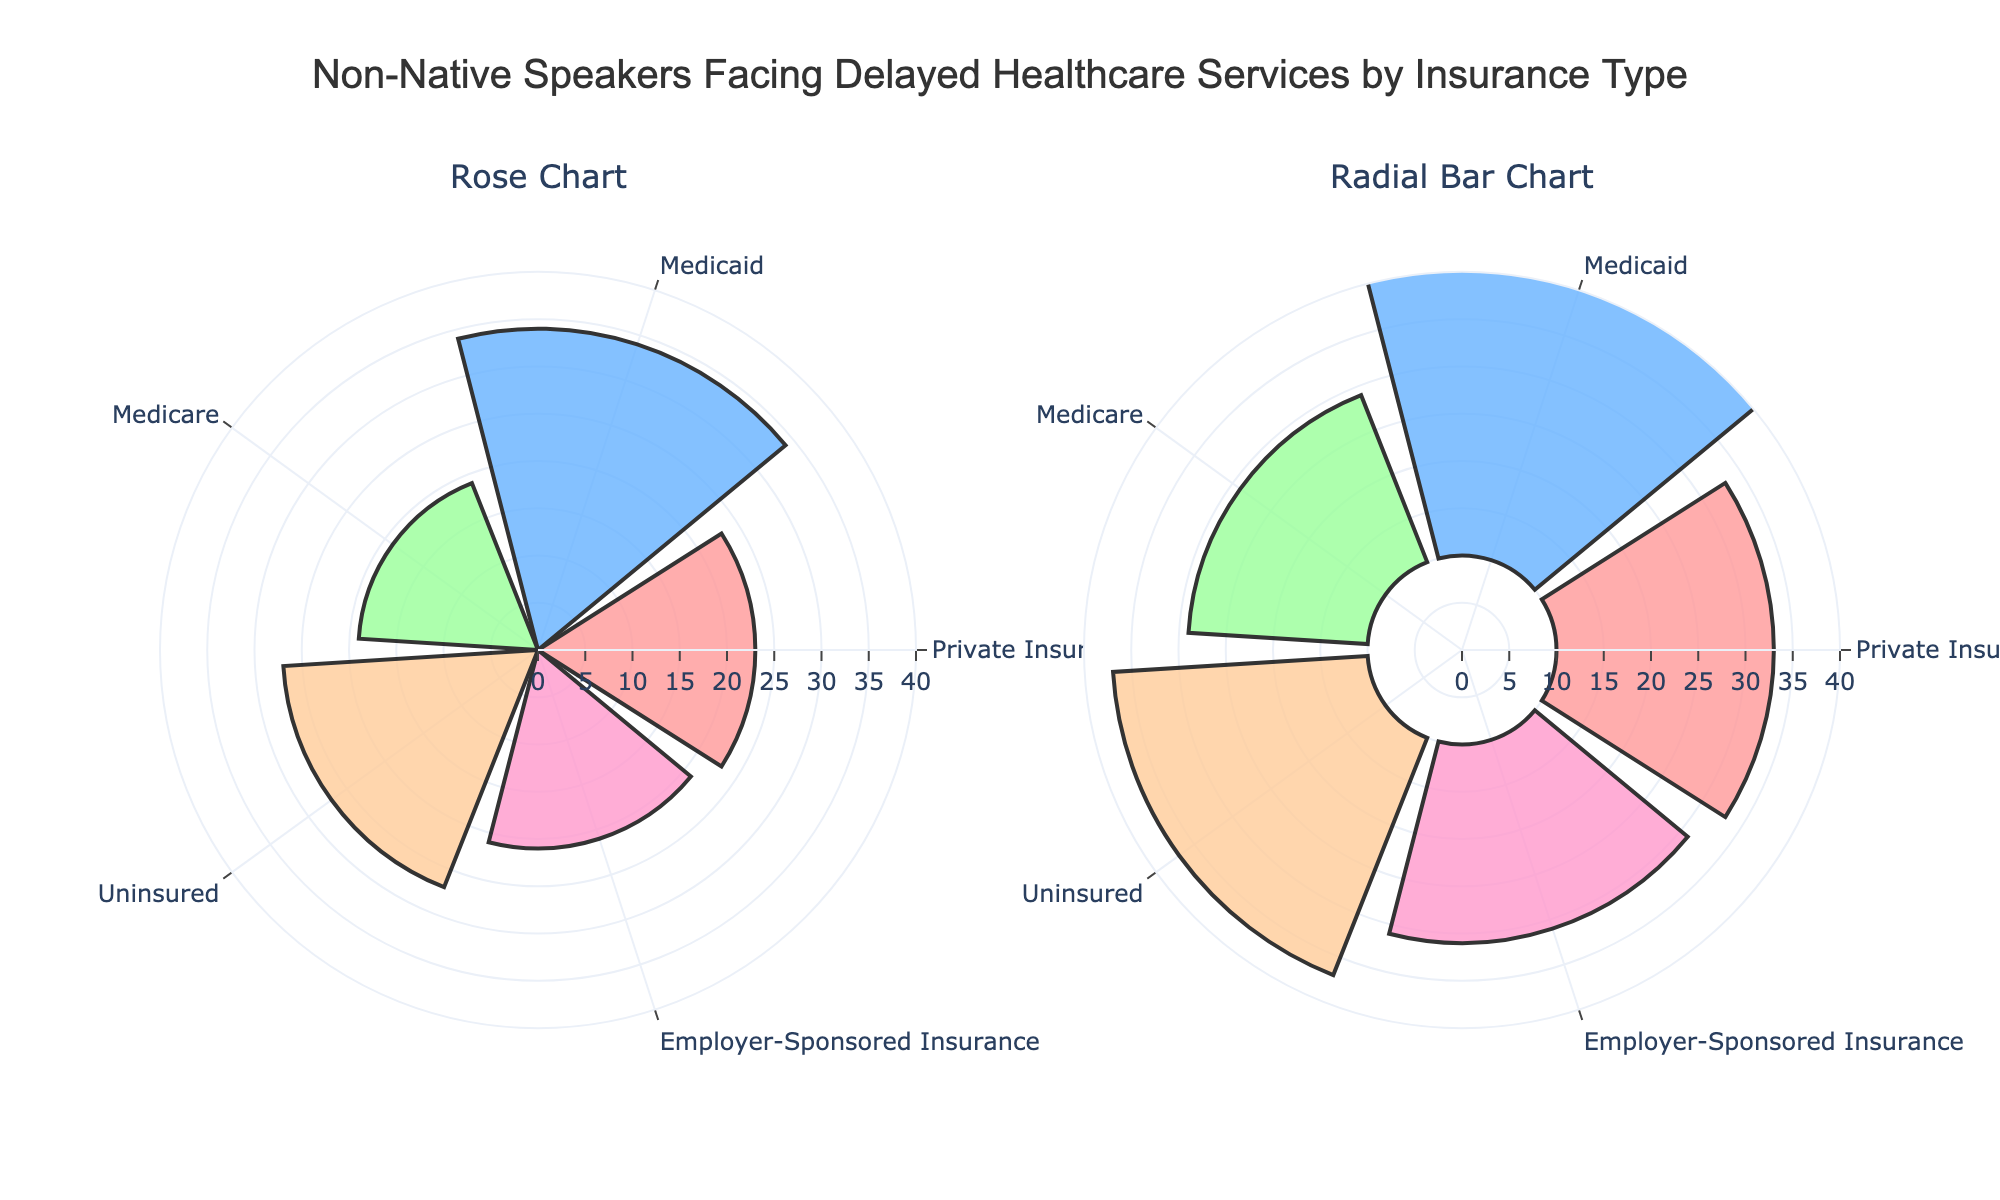What's the title of the figure? The title is usually at the top of the plot. In this case, it’s written clearly in a prominent position.
Answer: Non-Native Speakers Facing Delayed Healthcare Services by Insurance Type What are the insurance types shown in the figure? The insurance types are listed in the angular axis of the polar plots. Each bar in both charts corresponds to a different insurance type.
Answer: Private Insurance, Medicaid, Medicare, Uninsured, Employer-Sponsored Insurance How many non-native speakers face delays with Medicaid? Check the bar height corresponding to Medicaid. In both charts, the bar representing Medicaid shows the number of non-native speakers facing delays.
Answer: 34 Which insurance type has the highest number of non-native speakers facing delays? By comparing the heights of the bars, you can determine which bar is the tallest. The insurance type with the tallest bar represents the highest number of non-native speakers facing delays.
Answer: Medicaid What is the difference in the number of non-native speakers facing delays between Private Insurance and Uninsured? To find the difference, subtract the number for Private Insurance from the number for Uninsured: 27 - 23.
Answer: 4 Which insurance type has fewer non-native speakers facing delays than Medicaid but more than Employer-Sponsored Insurance? Look for the insurance type whose bar's height is between those of Medicaid (34) and Employer-Sponsored Insurance (21).
Answer: Uninsured Is there any insurance type with fewer than 20 non-native speakers facing delays? Check if any of the bar heights are less than 20. In this figure, compare each bar's value visually.
Answer: Yes, Medicare How many insurance types have more than 25 non-native speakers facing delays? Count the number of insurance types whose bar heights are above 25.
Answer: 3 (Medicaid, Uninsured, Private Insurance) What is the average number of non-native speakers facing delays across all insurance types? Sum all the values and divide by the number of insurance types: (23 + 34 + 19 + 27 + 21)/5 = 124/5.
Answer: 24.8 How does the second subplot (radial bar chart) differ visually from the first subplot (rose chart)? Compare the visual elements such as base position of the bars and any differences in representation. The radial bar might have different starting points for bars compared to the centered ones in a rose chart.
Answer: The radial bar chart has a base value different from zero 